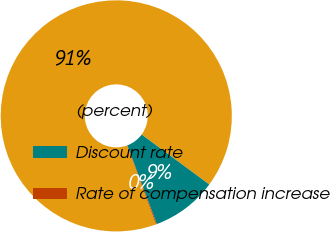Convert chart to OTSL. <chart><loc_0><loc_0><loc_500><loc_500><pie_chart><fcel>(percent)<fcel>Discount rate<fcel>Rate of compensation increase<nl><fcel>90.69%<fcel>9.18%<fcel>0.13%<nl></chart> 